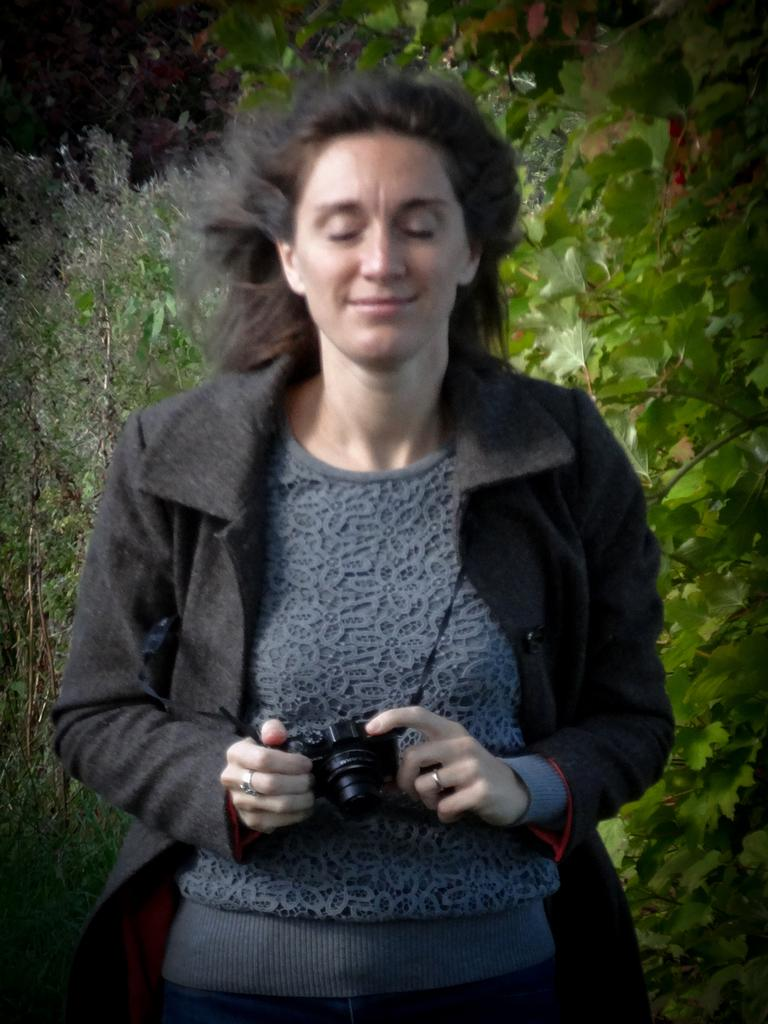Who is the main subject in the image? There is a woman in the image. What is the woman doing in the image? The woman is standing, closing her eyes, and smiling. What is the woman holding in her hands? The woman is holding a camera in her hands. What can be seen behind the woman in the image? There are plants behind the woman. What type of smoke can be seen coming from the camera in the image? There is no smoke coming from the camera in the image. The woman is holding a camera, but there is no indication of smoke or any other unusual activity involving the camera. 